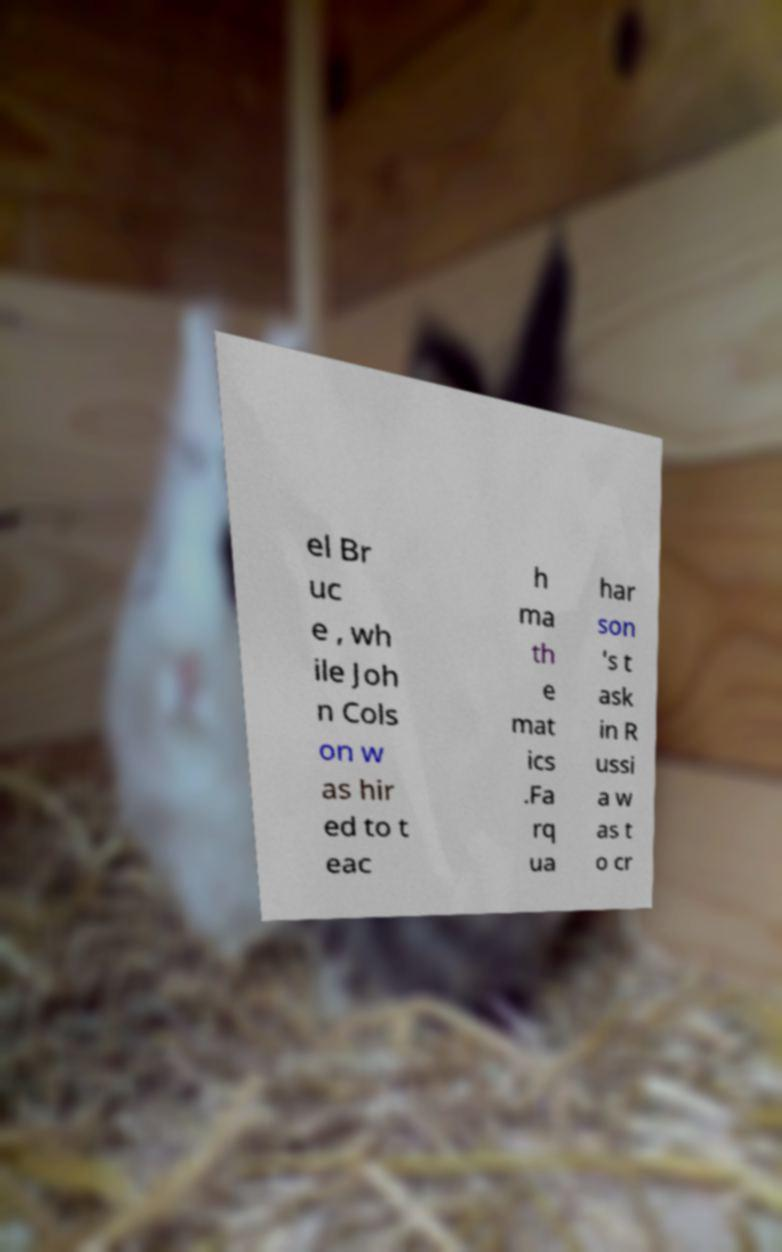I need the written content from this picture converted into text. Can you do that? el Br uc e , wh ile Joh n Cols on w as hir ed to t eac h ma th e mat ics .Fa rq ua har son 's t ask in R ussi a w as t o cr 